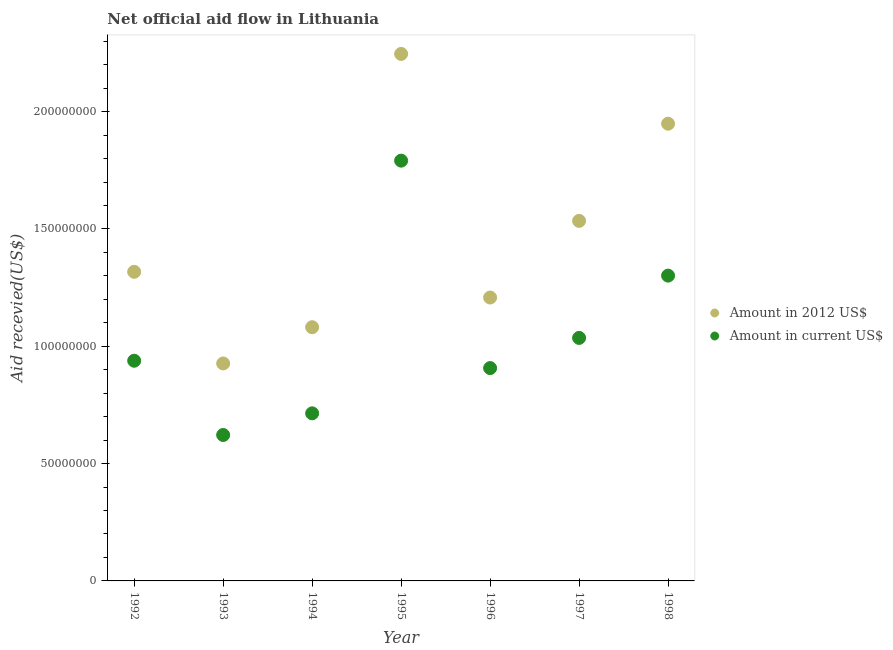How many different coloured dotlines are there?
Keep it short and to the point. 2. What is the amount of aid received(expressed in us$) in 1997?
Make the answer very short. 1.04e+08. Across all years, what is the maximum amount of aid received(expressed in 2012 us$)?
Keep it short and to the point. 2.25e+08. Across all years, what is the minimum amount of aid received(expressed in us$)?
Your answer should be compact. 6.22e+07. In which year was the amount of aid received(expressed in us$) maximum?
Provide a short and direct response. 1995. In which year was the amount of aid received(expressed in us$) minimum?
Offer a terse response. 1993. What is the total amount of aid received(expressed in us$) in the graph?
Offer a terse response. 7.31e+08. What is the difference between the amount of aid received(expressed in us$) in 1992 and that in 1994?
Provide a succinct answer. 2.24e+07. What is the difference between the amount of aid received(expressed in 2012 us$) in 1996 and the amount of aid received(expressed in us$) in 1998?
Your answer should be very brief. -9.34e+06. What is the average amount of aid received(expressed in us$) per year?
Ensure brevity in your answer.  1.04e+08. In the year 1994, what is the difference between the amount of aid received(expressed in 2012 us$) and amount of aid received(expressed in us$)?
Your answer should be compact. 3.67e+07. In how many years, is the amount of aid received(expressed in 2012 us$) greater than 70000000 US$?
Your response must be concise. 7. What is the ratio of the amount of aid received(expressed in 2012 us$) in 1994 to that in 1998?
Offer a terse response. 0.55. Is the difference between the amount of aid received(expressed in us$) in 1992 and 1996 greater than the difference between the amount of aid received(expressed in 2012 us$) in 1992 and 1996?
Your answer should be very brief. No. What is the difference between the highest and the second highest amount of aid received(expressed in us$)?
Your answer should be very brief. 4.90e+07. What is the difference between the highest and the lowest amount of aid received(expressed in us$)?
Provide a succinct answer. 1.17e+08. Is the amount of aid received(expressed in us$) strictly greater than the amount of aid received(expressed in 2012 us$) over the years?
Provide a short and direct response. No. Is the amount of aid received(expressed in us$) strictly less than the amount of aid received(expressed in 2012 us$) over the years?
Make the answer very short. Yes. How many dotlines are there?
Make the answer very short. 2. How many years are there in the graph?
Your answer should be compact. 7. Are the values on the major ticks of Y-axis written in scientific E-notation?
Offer a very short reply. No. Does the graph contain any zero values?
Ensure brevity in your answer.  No. Does the graph contain grids?
Provide a succinct answer. No. Where does the legend appear in the graph?
Your answer should be very brief. Center right. What is the title of the graph?
Ensure brevity in your answer.  Net official aid flow in Lithuania. What is the label or title of the X-axis?
Make the answer very short. Year. What is the label or title of the Y-axis?
Keep it short and to the point. Aid recevied(US$). What is the Aid recevied(US$) of Amount in 2012 US$ in 1992?
Provide a succinct answer. 1.32e+08. What is the Aid recevied(US$) in Amount in current US$ in 1992?
Your answer should be very brief. 9.38e+07. What is the Aid recevied(US$) of Amount in 2012 US$ in 1993?
Offer a terse response. 9.27e+07. What is the Aid recevied(US$) in Amount in current US$ in 1993?
Give a very brief answer. 6.22e+07. What is the Aid recevied(US$) of Amount in 2012 US$ in 1994?
Offer a terse response. 1.08e+08. What is the Aid recevied(US$) of Amount in current US$ in 1994?
Give a very brief answer. 7.14e+07. What is the Aid recevied(US$) of Amount in 2012 US$ in 1995?
Ensure brevity in your answer.  2.25e+08. What is the Aid recevied(US$) in Amount in current US$ in 1995?
Give a very brief answer. 1.79e+08. What is the Aid recevied(US$) of Amount in 2012 US$ in 1996?
Your response must be concise. 1.21e+08. What is the Aid recevied(US$) in Amount in current US$ in 1996?
Provide a succinct answer. 9.07e+07. What is the Aid recevied(US$) of Amount in 2012 US$ in 1997?
Give a very brief answer. 1.53e+08. What is the Aid recevied(US$) in Amount in current US$ in 1997?
Your answer should be compact. 1.04e+08. What is the Aid recevied(US$) of Amount in 2012 US$ in 1998?
Your answer should be very brief. 1.95e+08. What is the Aid recevied(US$) in Amount in current US$ in 1998?
Your answer should be very brief. 1.30e+08. Across all years, what is the maximum Aid recevied(US$) of Amount in 2012 US$?
Provide a succinct answer. 2.25e+08. Across all years, what is the maximum Aid recevied(US$) of Amount in current US$?
Your response must be concise. 1.79e+08. Across all years, what is the minimum Aid recevied(US$) of Amount in 2012 US$?
Make the answer very short. 9.27e+07. Across all years, what is the minimum Aid recevied(US$) in Amount in current US$?
Offer a terse response. 6.22e+07. What is the total Aid recevied(US$) of Amount in 2012 US$ in the graph?
Make the answer very short. 1.03e+09. What is the total Aid recevied(US$) of Amount in current US$ in the graph?
Keep it short and to the point. 7.31e+08. What is the difference between the Aid recevied(US$) of Amount in 2012 US$ in 1992 and that in 1993?
Offer a terse response. 3.91e+07. What is the difference between the Aid recevied(US$) in Amount in current US$ in 1992 and that in 1993?
Offer a very short reply. 3.16e+07. What is the difference between the Aid recevied(US$) of Amount in 2012 US$ in 1992 and that in 1994?
Keep it short and to the point. 2.36e+07. What is the difference between the Aid recevied(US$) in Amount in current US$ in 1992 and that in 1994?
Your response must be concise. 2.24e+07. What is the difference between the Aid recevied(US$) of Amount in 2012 US$ in 1992 and that in 1995?
Keep it short and to the point. -9.29e+07. What is the difference between the Aid recevied(US$) of Amount in current US$ in 1992 and that in 1995?
Offer a very short reply. -8.53e+07. What is the difference between the Aid recevied(US$) in Amount in 2012 US$ in 1992 and that in 1996?
Provide a succinct answer. 1.10e+07. What is the difference between the Aid recevied(US$) of Amount in current US$ in 1992 and that in 1996?
Keep it short and to the point. 3.13e+06. What is the difference between the Aid recevied(US$) in Amount in 2012 US$ in 1992 and that in 1997?
Your answer should be compact. -2.17e+07. What is the difference between the Aid recevied(US$) in Amount in current US$ in 1992 and that in 1997?
Provide a short and direct response. -9.73e+06. What is the difference between the Aid recevied(US$) in Amount in 2012 US$ in 1992 and that in 1998?
Your response must be concise. -6.31e+07. What is the difference between the Aid recevied(US$) in Amount in current US$ in 1992 and that in 1998?
Provide a succinct answer. -3.63e+07. What is the difference between the Aid recevied(US$) of Amount in 2012 US$ in 1993 and that in 1994?
Your answer should be very brief. -1.54e+07. What is the difference between the Aid recevied(US$) in Amount in current US$ in 1993 and that in 1994?
Make the answer very short. -9.23e+06. What is the difference between the Aid recevied(US$) in Amount in 2012 US$ in 1993 and that in 1995?
Offer a very short reply. -1.32e+08. What is the difference between the Aid recevied(US$) in Amount in current US$ in 1993 and that in 1995?
Your answer should be very brief. -1.17e+08. What is the difference between the Aid recevied(US$) in Amount in 2012 US$ in 1993 and that in 1996?
Give a very brief answer. -2.81e+07. What is the difference between the Aid recevied(US$) in Amount in current US$ in 1993 and that in 1996?
Provide a succinct answer. -2.85e+07. What is the difference between the Aid recevied(US$) in Amount in 2012 US$ in 1993 and that in 1997?
Offer a very short reply. -6.08e+07. What is the difference between the Aid recevied(US$) in Amount in current US$ in 1993 and that in 1997?
Keep it short and to the point. -4.14e+07. What is the difference between the Aid recevied(US$) in Amount in 2012 US$ in 1993 and that in 1998?
Your answer should be compact. -1.02e+08. What is the difference between the Aid recevied(US$) in Amount in current US$ in 1993 and that in 1998?
Offer a very short reply. -6.79e+07. What is the difference between the Aid recevied(US$) of Amount in 2012 US$ in 1994 and that in 1995?
Give a very brief answer. -1.16e+08. What is the difference between the Aid recevied(US$) in Amount in current US$ in 1994 and that in 1995?
Keep it short and to the point. -1.08e+08. What is the difference between the Aid recevied(US$) of Amount in 2012 US$ in 1994 and that in 1996?
Make the answer very short. -1.26e+07. What is the difference between the Aid recevied(US$) of Amount in current US$ in 1994 and that in 1996?
Your response must be concise. -1.93e+07. What is the difference between the Aid recevied(US$) of Amount in 2012 US$ in 1994 and that in 1997?
Your response must be concise. -4.53e+07. What is the difference between the Aid recevied(US$) in Amount in current US$ in 1994 and that in 1997?
Keep it short and to the point. -3.22e+07. What is the difference between the Aid recevied(US$) in Amount in 2012 US$ in 1994 and that in 1998?
Ensure brevity in your answer.  -8.67e+07. What is the difference between the Aid recevied(US$) in Amount in current US$ in 1994 and that in 1998?
Your answer should be compact. -5.87e+07. What is the difference between the Aid recevied(US$) of Amount in 2012 US$ in 1995 and that in 1996?
Your answer should be compact. 1.04e+08. What is the difference between the Aid recevied(US$) of Amount in current US$ in 1995 and that in 1996?
Your answer should be very brief. 8.84e+07. What is the difference between the Aid recevied(US$) of Amount in 2012 US$ in 1995 and that in 1997?
Keep it short and to the point. 7.12e+07. What is the difference between the Aid recevied(US$) of Amount in current US$ in 1995 and that in 1997?
Keep it short and to the point. 7.56e+07. What is the difference between the Aid recevied(US$) of Amount in 2012 US$ in 1995 and that in 1998?
Keep it short and to the point. 2.97e+07. What is the difference between the Aid recevied(US$) in Amount in current US$ in 1995 and that in 1998?
Make the answer very short. 4.90e+07. What is the difference between the Aid recevied(US$) in Amount in 2012 US$ in 1996 and that in 1997?
Give a very brief answer. -3.27e+07. What is the difference between the Aid recevied(US$) of Amount in current US$ in 1996 and that in 1997?
Your answer should be compact. -1.29e+07. What is the difference between the Aid recevied(US$) in Amount in 2012 US$ in 1996 and that in 1998?
Your answer should be very brief. -7.41e+07. What is the difference between the Aid recevied(US$) in Amount in current US$ in 1996 and that in 1998?
Offer a very short reply. -3.94e+07. What is the difference between the Aid recevied(US$) of Amount in 2012 US$ in 1997 and that in 1998?
Provide a succinct answer. -4.14e+07. What is the difference between the Aid recevied(US$) of Amount in current US$ in 1997 and that in 1998?
Offer a terse response. -2.66e+07. What is the difference between the Aid recevied(US$) in Amount in 2012 US$ in 1992 and the Aid recevied(US$) in Amount in current US$ in 1993?
Ensure brevity in your answer.  6.96e+07. What is the difference between the Aid recevied(US$) in Amount in 2012 US$ in 1992 and the Aid recevied(US$) in Amount in current US$ in 1994?
Provide a short and direct response. 6.03e+07. What is the difference between the Aid recevied(US$) of Amount in 2012 US$ in 1992 and the Aid recevied(US$) of Amount in current US$ in 1995?
Offer a terse response. -4.74e+07. What is the difference between the Aid recevied(US$) of Amount in 2012 US$ in 1992 and the Aid recevied(US$) of Amount in current US$ in 1996?
Your answer should be very brief. 4.10e+07. What is the difference between the Aid recevied(US$) in Amount in 2012 US$ in 1992 and the Aid recevied(US$) in Amount in current US$ in 1997?
Make the answer very short. 2.82e+07. What is the difference between the Aid recevied(US$) in Amount in 2012 US$ in 1992 and the Aid recevied(US$) in Amount in current US$ in 1998?
Make the answer very short. 1.62e+06. What is the difference between the Aid recevied(US$) in Amount in 2012 US$ in 1993 and the Aid recevied(US$) in Amount in current US$ in 1994?
Your response must be concise. 2.13e+07. What is the difference between the Aid recevied(US$) of Amount in 2012 US$ in 1993 and the Aid recevied(US$) of Amount in current US$ in 1995?
Your answer should be compact. -8.64e+07. What is the difference between the Aid recevied(US$) of Amount in 2012 US$ in 1993 and the Aid recevied(US$) of Amount in current US$ in 1996?
Offer a very short reply. 1.97e+06. What is the difference between the Aid recevied(US$) in Amount in 2012 US$ in 1993 and the Aid recevied(US$) in Amount in current US$ in 1997?
Your response must be concise. -1.09e+07. What is the difference between the Aid recevied(US$) in Amount in 2012 US$ in 1993 and the Aid recevied(US$) in Amount in current US$ in 1998?
Your response must be concise. -3.74e+07. What is the difference between the Aid recevied(US$) of Amount in 2012 US$ in 1994 and the Aid recevied(US$) of Amount in current US$ in 1995?
Your response must be concise. -7.10e+07. What is the difference between the Aid recevied(US$) of Amount in 2012 US$ in 1994 and the Aid recevied(US$) of Amount in current US$ in 1996?
Your answer should be compact. 1.74e+07. What is the difference between the Aid recevied(US$) of Amount in 2012 US$ in 1994 and the Aid recevied(US$) of Amount in current US$ in 1997?
Your answer should be very brief. 4.56e+06. What is the difference between the Aid recevied(US$) in Amount in 2012 US$ in 1994 and the Aid recevied(US$) in Amount in current US$ in 1998?
Offer a very short reply. -2.20e+07. What is the difference between the Aid recevied(US$) of Amount in 2012 US$ in 1995 and the Aid recevied(US$) of Amount in current US$ in 1996?
Provide a short and direct response. 1.34e+08. What is the difference between the Aid recevied(US$) of Amount in 2012 US$ in 1995 and the Aid recevied(US$) of Amount in current US$ in 1997?
Provide a short and direct response. 1.21e+08. What is the difference between the Aid recevied(US$) in Amount in 2012 US$ in 1995 and the Aid recevied(US$) in Amount in current US$ in 1998?
Make the answer very short. 9.45e+07. What is the difference between the Aid recevied(US$) of Amount in 2012 US$ in 1996 and the Aid recevied(US$) of Amount in current US$ in 1997?
Your answer should be compact. 1.72e+07. What is the difference between the Aid recevied(US$) of Amount in 2012 US$ in 1996 and the Aid recevied(US$) of Amount in current US$ in 1998?
Offer a very short reply. -9.34e+06. What is the difference between the Aid recevied(US$) of Amount in 2012 US$ in 1997 and the Aid recevied(US$) of Amount in current US$ in 1998?
Your response must be concise. 2.33e+07. What is the average Aid recevied(US$) of Amount in 2012 US$ per year?
Your answer should be compact. 1.47e+08. What is the average Aid recevied(US$) in Amount in current US$ per year?
Ensure brevity in your answer.  1.04e+08. In the year 1992, what is the difference between the Aid recevied(US$) in Amount in 2012 US$ and Aid recevied(US$) in Amount in current US$?
Offer a terse response. 3.79e+07. In the year 1993, what is the difference between the Aid recevied(US$) in Amount in 2012 US$ and Aid recevied(US$) in Amount in current US$?
Your answer should be very brief. 3.05e+07. In the year 1994, what is the difference between the Aid recevied(US$) in Amount in 2012 US$ and Aid recevied(US$) in Amount in current US$?
Make the answer very short. 3.67e+07. In the year 1995, what is the difference between the Aid recevied(US$) in Amount in 2012 US$ and Aid recevied(US$) in Amount in current US$?
Offer a terse response. 4.55e+07. In the year 1996, what is the difference between the Aid recevied(US$) of Amount in 2012 US$ and Aid recevied(US$) of Amount in current US$?
Your response must be concise. 3.01e+07. In the year 1997, what is the difference between the Aid recevied(US$) in Amount in 2012 US$ and Aid recevied(US$) in Amount in current US$?
Ensure brevity in your answer.  4.99e+07. In the year 1998, what is the difference between the Aid recevied(US$) of Amount in 2012 US$ and Aid recevied(US$) of Amount in current US$?
Your answer should be very brief. 6.48e+07. What is the ratio of the Aid recevied(US$) in Amount in 2012 US$ in 1992 to that in 1993?
Ensure brevity in your answer.  1.42. What is the ratio of the Aid recevied(US$) in Amount in current US$ in 1992 to that in 1993?
Keep it short and to the point. 1.51. What is the ratio of the Aid recevied(US$) in Amount in 2012 US$ in 1992 to that in 1994?
Your response must be concise. 1.22. What is the ratio of the Aid recevied(US$) of Amount in current US$ in 1992 to that in 1994?
Give a very brief answer. 1.31. What is the ratio of the Aid recevied(US$) in Amount in 2012 US$ in 1992 to that in 1995?
Give a very brief answer. 0.59. What is the ratio of the Aid recevied(US$) in Amount in current US$ in 1992 to that in 1995?
Make the answer very short. 0.52. What is the ratio of the Aid recevied(US$) in Amount in 2012 US$ in 1992 to that in 1996?
Ensure brevity in your answer.  1.09. What is the ratio of the Aid recevied(US$) in Amount in current US$ in 1992 to that in 1996?
Make the answer very short. 1.03. What is the ratio of the Aid recevied(US$) of Amount in 2012 US$ in 1992 to that in 1997?
Your answer should be very brief. 0.86. What is the ratio of the Aid recevied(US$) in Amount in current US$ in 1992 to that in 1997?
Give a very brief answer. 0.91. What is the ratio of the Aid recevied(US$) in Amount in 2012 US$ in 1992 to that in 1998?
Your response must be concise. 0.68. What is the ratio of the Aid recevied(US$) of Amount in current US$ in 1992 to that in 1998?
Provide a short and direct response. 0.72. What is the ratio of the Aid recevied(US$) in Amount in 2012 US$ in 1993 to that in 1994?
Provide a succinct answer. 0.86. What is the ratio of the Aid recevied(US$) of Amount in current US$ in 1993 to that in 1994?
Give a very brief answer. 0.87. What is the ratio of the Aid recevied(US$) in Amount in 2012 US$ in 1993 to that in 1995?
Provide a succinct answer. 0.41. What is the ratio of the Aid recevied(US$) of Amount in current US$ in 1993 to that in 1995?
Make the answer very short. 0.35. What is the ratio of the Aid recevied(US$) of Amount in 2012 US$ in 1993 to that in 1996?
Make the answer very short. 0.77. What is the ratio of the Aid recevied(US$) of Amount in current US$ in 1993 to that in 1996?
Your response must be concise. 0.69. What is the ratio of the Aid recevied(US$) in Amount in 2012 US$ in 1993 to that in 1997?
Your answer should be compact. 0.6. What is the ratio of the Aid recevied(US$) of Amount in current US$ in 1993 to that in 1997?
Your response must be concise. 0.6. What is the ratio of the Aid recevied(US$) of Amount in 2012 US$ in 1993 to that in 1998?
Offer a very short reply. 0.48. What is the ratio of the Aid recevied(US$) of Amount in current US$ in 1993 to that in 1998?
Offer a very short reply. 0.48. What is the ratio of the Aid recevied(US$) of Amount in 2012 US$ in 1994 to that in 1995?
Your answer should be compact. 0.48. What is the ratio of the Aid recevied(US$) of Amount in current US$ in 1994 to that in 1995?
Offer a very short reply. 0.4. What is the ratio of the Aid recevied(US$) in Amount in 2012 US$ in 1994 to that in 1996?
Offer a terse response. 0.9. What is the ratio of the Aid recevied(US$) in Amount in current US$ in 1994 to that in 1996?
Make the answer very short. 0.79. What is the ratio of the Aid recevied(US$) in Amount in 2012 US$ in 1994 to that in 1997?
Provide a succinct answer. 0.7. What is the ratio of the Aid recevied(US$) of Amount in current US$ in 1994 to that in 1997?
Your response must be concise. 0.69. What is the ratio of the Aid recevied(US$) of Amount in 2012 US$ in 1994 to that in 1998?
Your answer should be compact. 0.55. What is the ratio of the Aid recevied(US$) of Amount in current US$ in 1994 to that in 1998?
Make the answer very short. 0.55. What is the ratio of the Aid recevied(US$) of Amount in 2012 US$ in 1995 to that in 1996?
Ensure brevity in your answer.  1.86. What is the ratio of the Aid recevied(US$) in Amount in current US$ in 1995 to that in 1996?
Ensure brevity in your answer.  1.97. What is the ratio of the Aid recevied(US$) of Amount in 2012 US$ in 1995 to that in 1997?
Your answer should be compact. 1.46. What is the ratio of the Aid recevied(US$) of Amount in current US$ in 1995 to that in 1997?
Your response must be concise. 1.73. What is the ratio of the Aid recevied(US$) of Amount in 2012 US$ in 1995 to that in 1998?
Give a very brief answer. 1.15. What is the ratio of the Aid recevied(US$) of Amount in current US$ in 1995 to that in 1998?
Provide a succinct answer. 1.38. What is the ratio of the Aid recevied(US$) in Amount in 2012 US$ in 1996 to that in 1997?
Make the answer very short. 0.79. What is the ratio of the Aid recevied(US$) of Amount in current US$ in 1996 to that in 1997?
Provide a short and direct response. 0.88. What is the ratio of the Aid recevied(US$) of Amount in 2012 US$ in 1996 to that in 1998?
Your response must be concise. 0.62. What is the ratio of the Aid recevied(US$) of Amount in current US$ in 1996 to that in 1998?
Ensure brevity in your answer.  0.7. What is the ratio of the Aid recevied(US$) of Amount in 2012 US$ in 1997 to that in 1998?
Offer a very short reply. 0.79. What is the ratio of the Aid recevied(US$) of Amount in current US$ in 1997 to that in 1998?
Your answer should be very brief. 0.8. What is the difference between the highest and the second highest Aid recevied(US$) in Amount in 2012 US$?
Ensure brevity in your answer.  2.97e+07. What is the difference between the highest and the second highest Aid recevied(US$) of Amount in current US$?
Your answer should be compact. 4.90e+07. What is the difference between the highest and the lowest Aid recevied(US$) in Amount in 2012 US$?
Offer a terse response. 1.32e+08. What is the difference between the highest and the lowest Aid recevied(US$) of Amount in current US$?
Offer a terse response. 1.17e+08. 